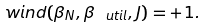<formula> <loc_0><loc_0><loc_500><loc_500>\ w i n d ( \beta _ { N } , \beta _ { \ u t i l } , J ) = + 1 .</formula> 